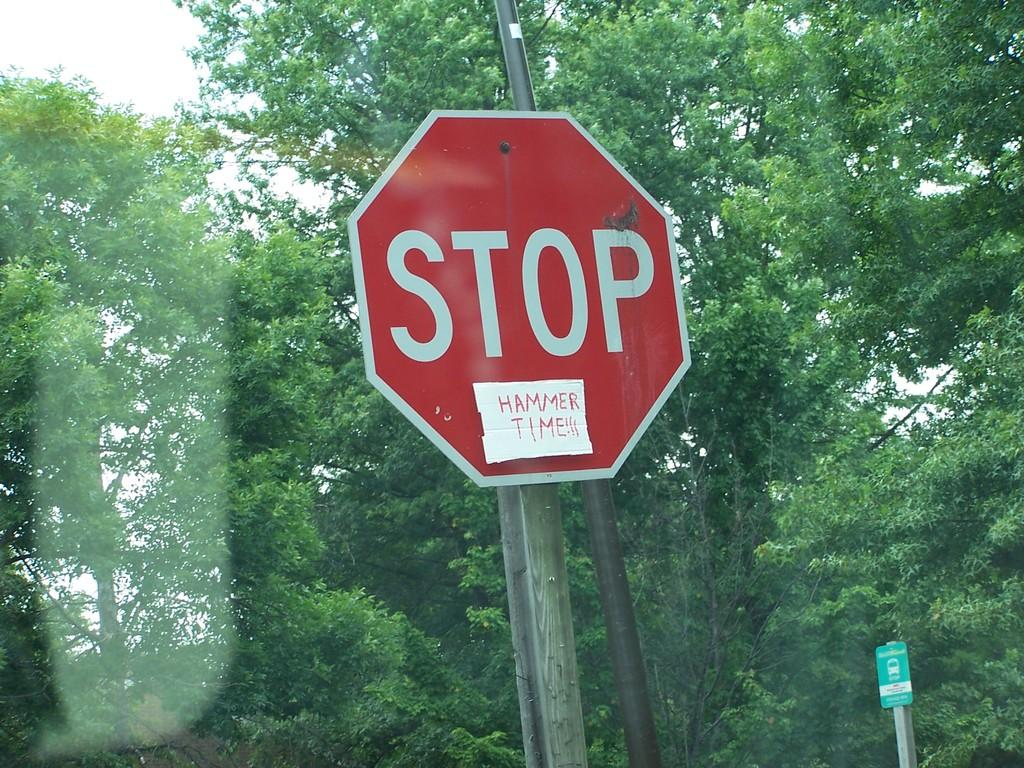<image>
Offer a succinct explanation of the picture presented. A stop sign with a piece of cardboard that says Hammer Time below it. 